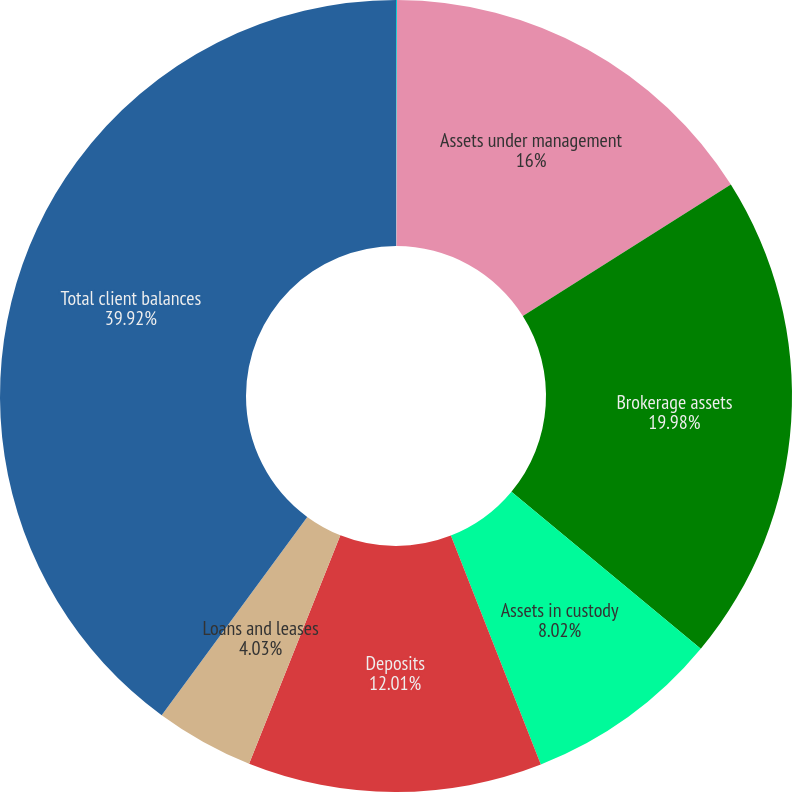Convert chart. <chart><loc_0><loc_0><loc_500><loc_500><pie_chart><fcel>(Dollars in millions)<fcel>Assets under management<fcel>Brokerage assets<fcel>Assets in custody<fcel>Deposits<fcel>Loans and leases<fcel>Total client balances<nl><fcel>0.04%<fcel>16.0%<fcel>19.99%<fcel>8.02%<fcel>12.01%<fcel>4.03%<fcel>39.93%<nl></chart> 